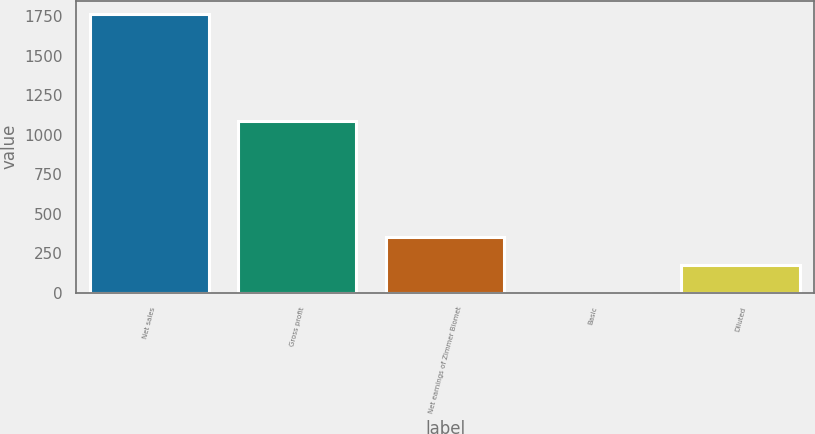Convert chart. <chart><loc_0><loc_0><loc_500><loc_500><bar_chart><fcel>Net sales<fcel>Gross profit<fcel>Net earnings of Zimmer Biomet<fcel>Basic<fcel>Diluted<nl><fcel>1762.2<fcel>1087.5<fcel>352.53<fcel>0.11<fcel>176.32<nl></chart> 